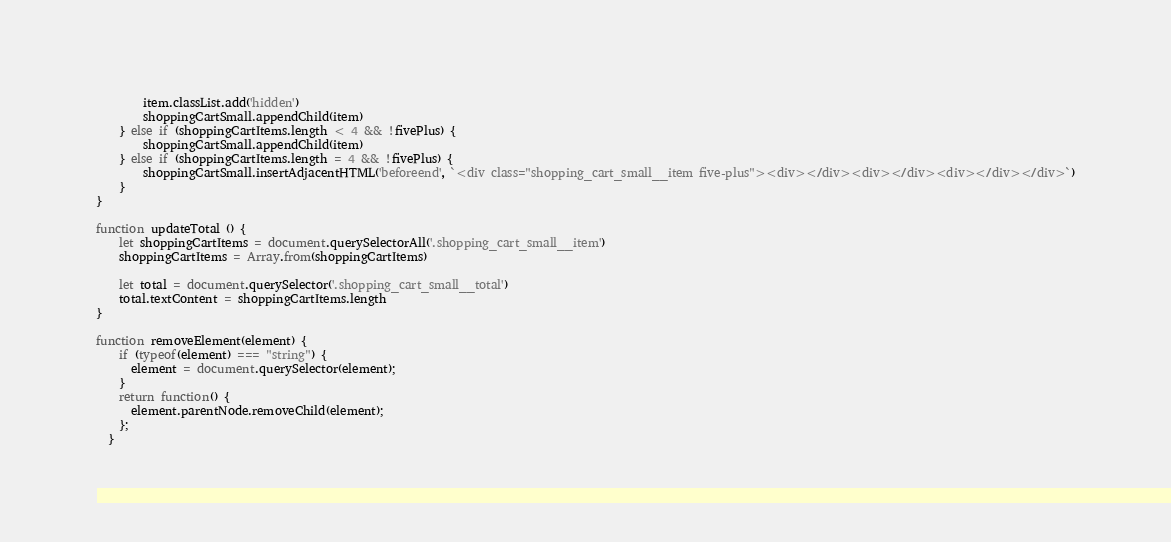<code> <loc_0><loc_0><loc_500><loc_500><_JavaScript_>        item.classList.add('hidden')
        shoppingCartSmall.appendChild(item)
    } else if (shoppingCartItems.length < 4 && !fivePlus) {
        shoppingCartSmall.appendChild(item)
    } else if (shoppingCartItems.length = 4 && !fivePlus) {
        shoppingCartSmall.insertAdjacentHTML('beforeend', `<div class="shopping_cart_small__item five-plus"><div></div><div></div><div></div></div>`)
    }
}

function updateTotal () {
    let shoppingCartItems = document.querySelectorAll('.shopping_cart_small__item')
    shoppingCartItems = Array.from(shoppingCartItems)

    let total = document.querySelector('.shopping_cart_small__total')
    total.textContent = shoppingCartItems.length
}

function removeElement(element) {
    if (typeof(element) === "string") {
      element = document.querySelector(element);
    }
    return function() {
      element.parentNode.removeChild(element);
    };
  }</code> 